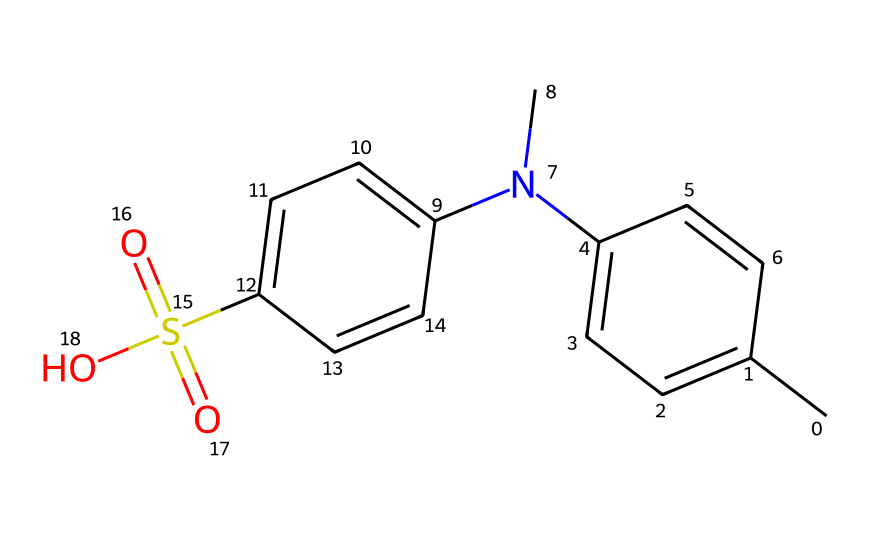What is the primary functional group present in this molecule? The molecule contains a sulfonic acid group as indicated by the presence of the sulfur atom bonded to oxygen and the hydroxyl group (-S(=O)(=O)O).
Answer: sulfonic acid How many carbon atoms are there in this chemical structure? By counting the carbon (C) atoms in the provided SMILES representation, there are a total of 12 carbon atoms in the molecule.
Answer: 12 What type of bonding is observed between the carbon atoms? The carbon atoms in this structure are primarily involved in covalent bonding with each other, connected through single and double bonds as depicted in the structure.
Answer: covalent Which part of the molecule contributes to its photoreactive properties? The presence of the conjugated double bonds in the aromatic rings enables the molecule to absorb light, thereby contributing to its photoreactive properties.
Answer: conjugated double bonds How many nitrogen atoms are present in the structure? The SMILES representation shows one nitrogen (N) atom in the molecule, which is a part of a tertiary amine.
Answer: 1 What is the role of the sulfonic acid group in photoreactive chemicals? The sulfonic acid group can enhance solubility and reactivity, which may improve the effectiveness of the photoreactive response when light is absorbed.
Answer: enhances solubility 